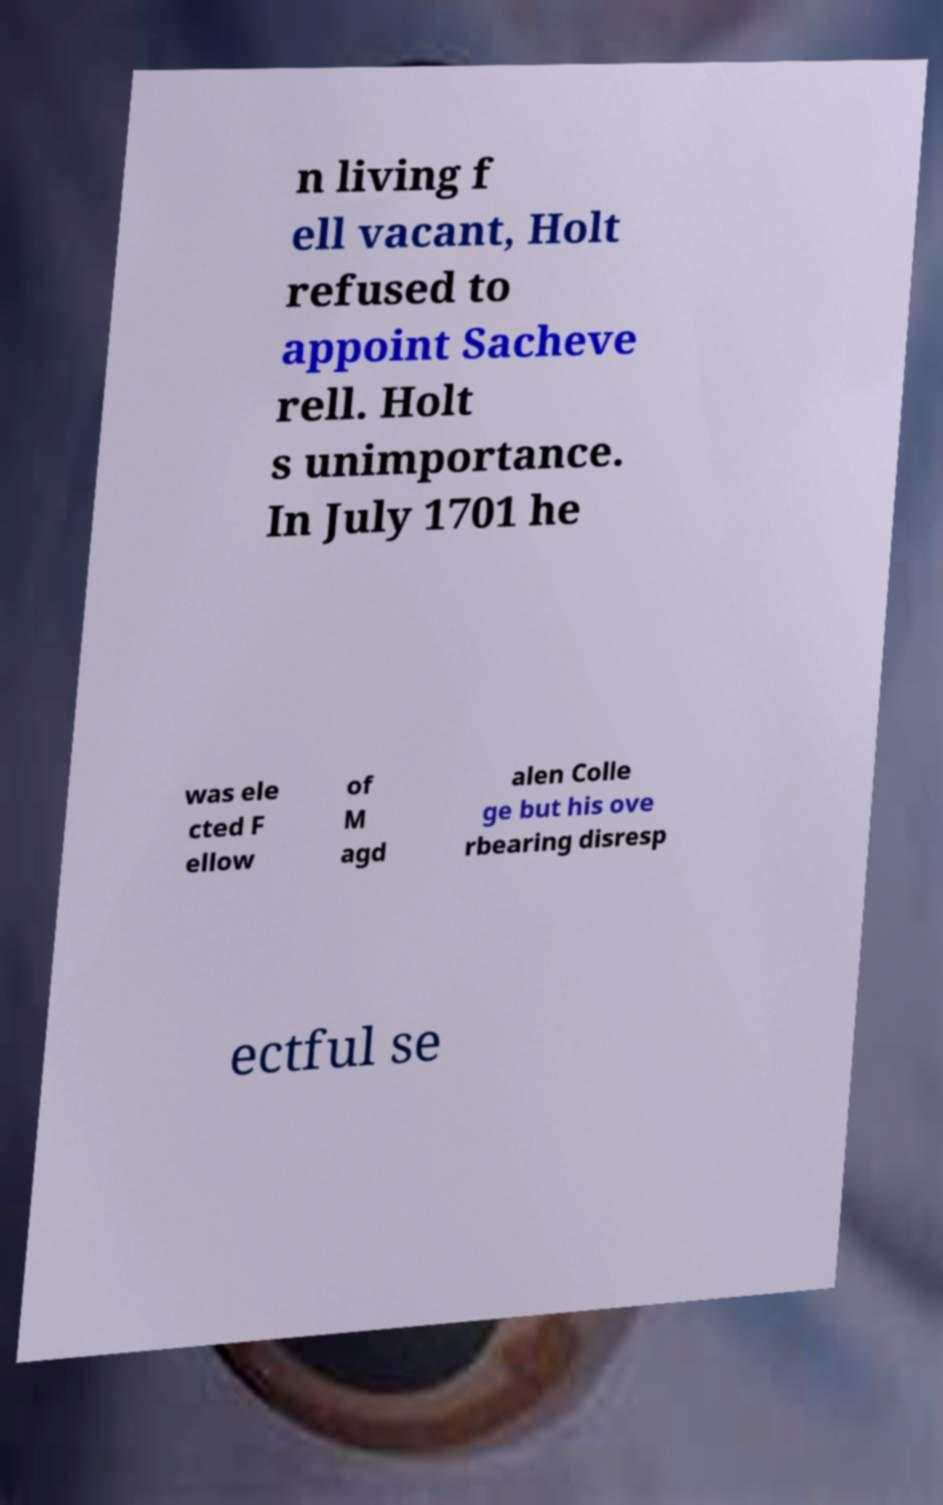What messages or text are displayed in this image? I need them in a readable, typed format. n living f ell vacant, Holt refused to appoint Sacheve rell. Holt s unimportance. In July 1701 he was ele cted F ellow of M agd alen Colle ge but his ove rbearing disresp ectful se 